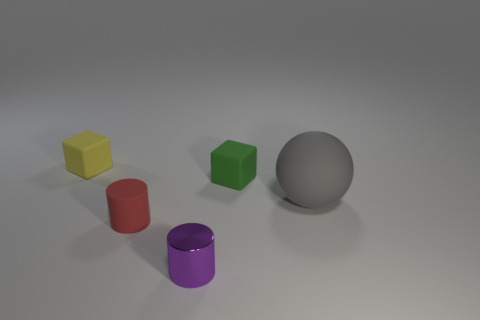The red rubber thing is what size?
Ensure brevity in your answer.  Small. There is a red matte object; does it have the same size as the rubber block that is on the right side of the tiny purple metallic thing?
Ensure brevity in your answer.  Yes. What is the color of the cylinder in front of the matte object in front of the big ball?
Give a very brief answer. Purple. Is the number of tiny red objects left of the green rubber cube the same as the number of small red cylinders that are in front of the gray sphere?
Provide a succinct answer. Yes. Are the cylinder that is behind the tiny metal cylinder and the tiny purple thing made of the same material?
Provide a short and direct response. No. There is a tiny matte thing that is in front of the small yellow matte thing and to the left of the green object; what is its color?
Offer a terse response. Red. What number of small metallic cylinders are behind the small matte cube that is in front of the yellow block?
Provide a short and direct response. 0. What material is the other thing that is the same shape as the purple metallic thing?
Make the answer very short. Rubber. The rubber ball is what color?
Your answer should be compact. Gray. What number of things are large brown things or matte cylinders?
Offer a very short reply. 1. 